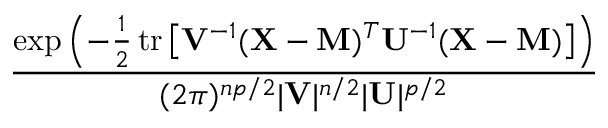Convert formula to latex. <formula><loc_0><loc_0><loc_500><loc_500>\frac { \exp \left ( - { \frac { 1 } { 2 } } \, t r \left [ V ^ { - 1 } ( X - M ) ^ { T } U ^ { - 1 } ( X - M ) \right ] \right ) } { ( 2 \pi ) ^ { n p / 2 } | V | ^ { n / 2 } | U | ^ { p / 2 } }</formula> 